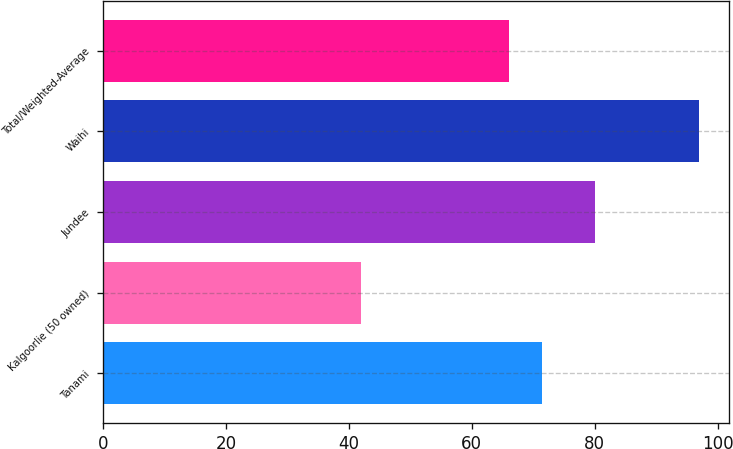Convert chart. <chart><loc_0><loc_0><loc_500><loc_500><bar_chart><fcel>Tanami<fcel>Kalgoorlie (50 owned)<fcel>Jundee<fcel>Waihi<fcel>Total/Weighted-Average<nl><fcel>71.5<fcel>42<fcel>80<fcel>97<fcel>66<nl></chart> 